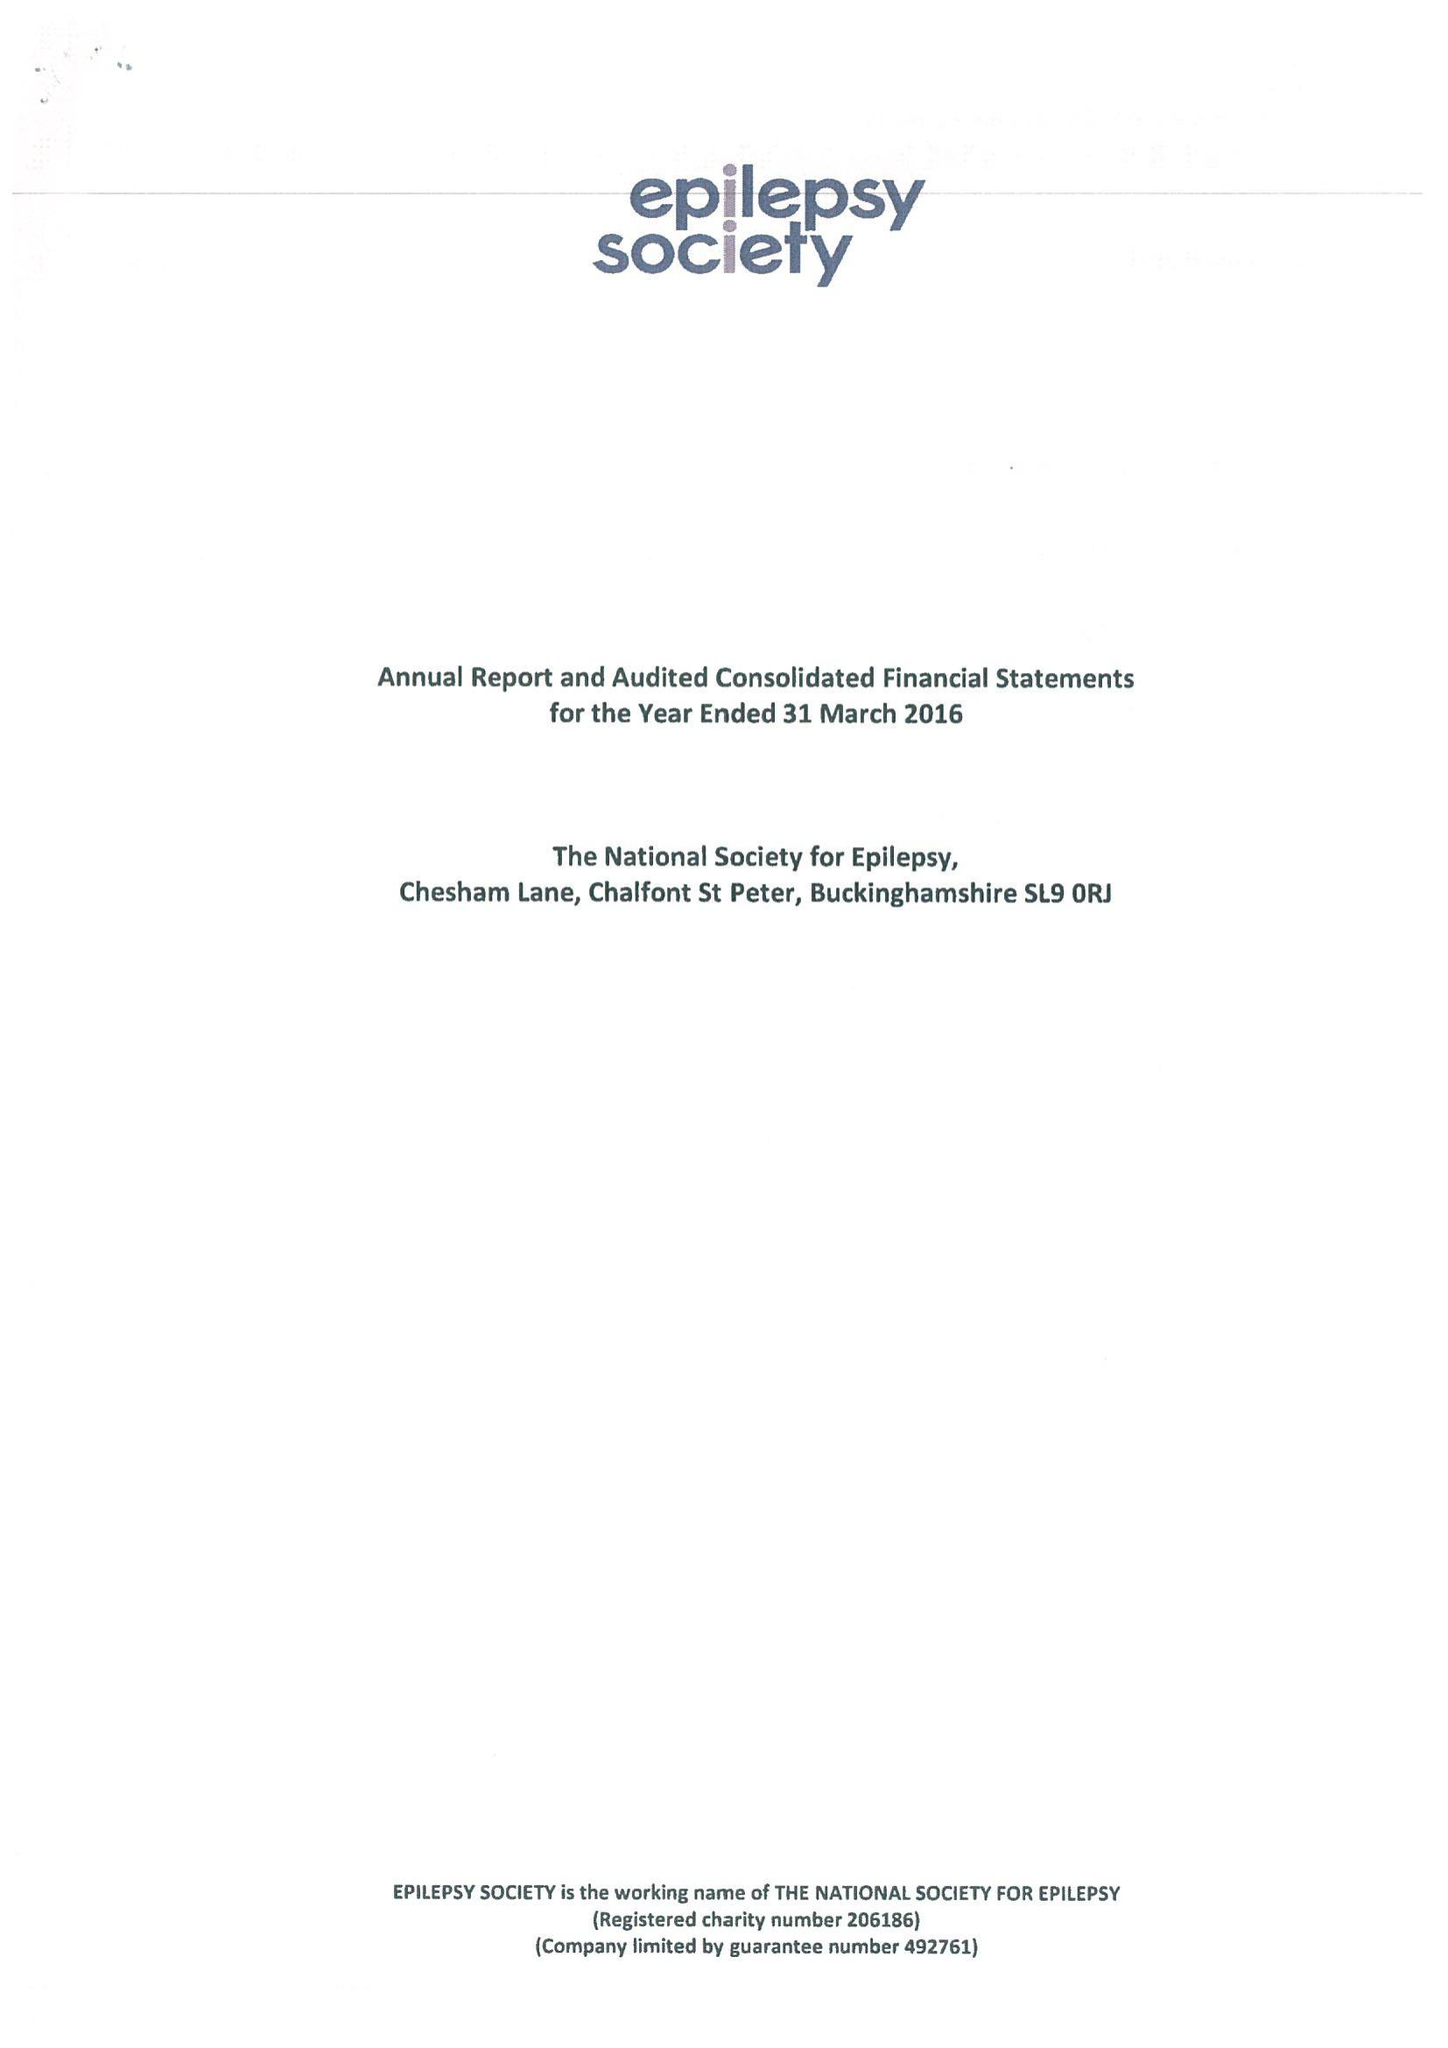What is the value for the income_annually_in_british_pounds?
Answer the question using a single word or phrase. 16992000.00 